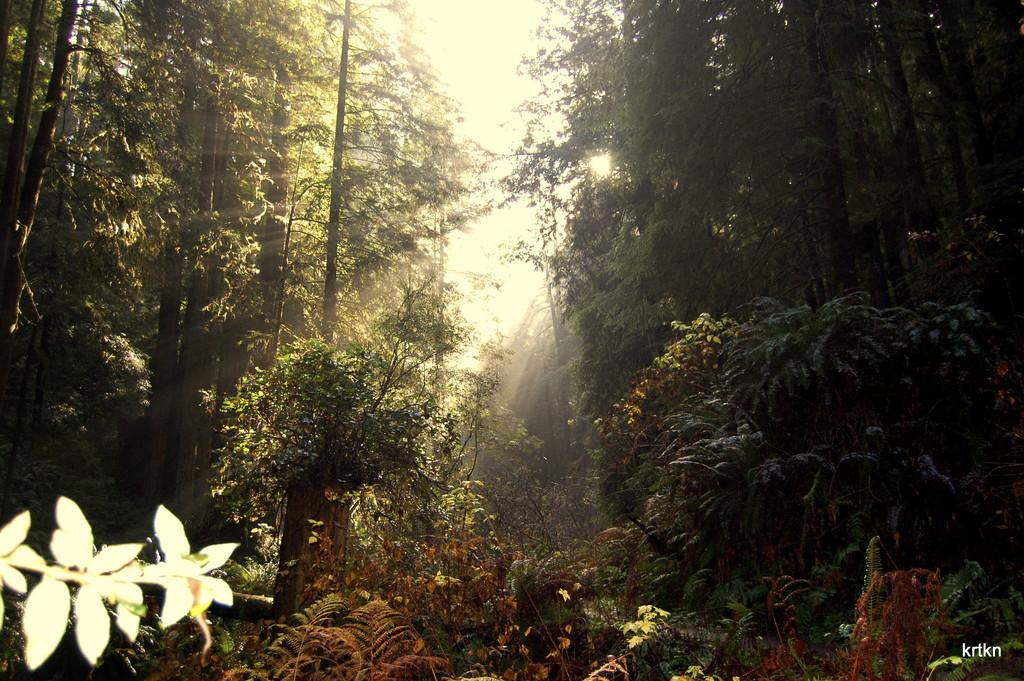What type of vegetation is present in the image? There are tall trees in the image. What can be observed in the sky in the image? Sunlight is visible in the image. How many horses are present in the image? There are no horses present in the image; it only features tall trees and sunlight. What type of company is depicted in the image? There is no company depicted in the image; it only features tall trees and sunlight. 